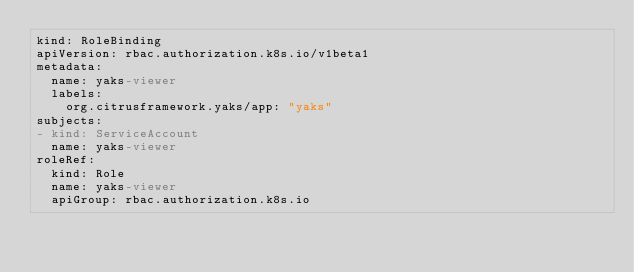Convert code to text. <code><loc_0><loc_0><loc_500><loc_500><_YAML_>kind: RoleBinding
apiVersion: rbac.authorization.k8s.io/v1beta1
metadata:
  name: yaks-viewer
  labels:
    org.citrusframework.yaks/app: "yaks"
subjects:
- kind: ServiceAccount
  name: yaks-viewer
roleRef:
  kind: Role
  name: yaks-viewer
  apiGroup: rbac.authorization.k8s.io
</code> 